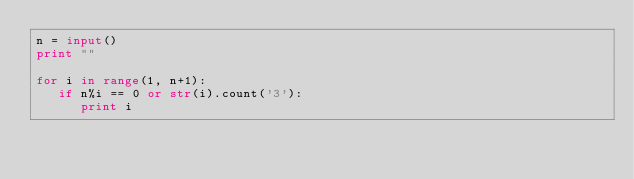<code> <loc_0><loc_0><loc_500><loc_500><_Python_>n = input()
print ""

for i in range(1, n+1):
   if n%i == 0 or str(i).count('3'):
      print i</code> 